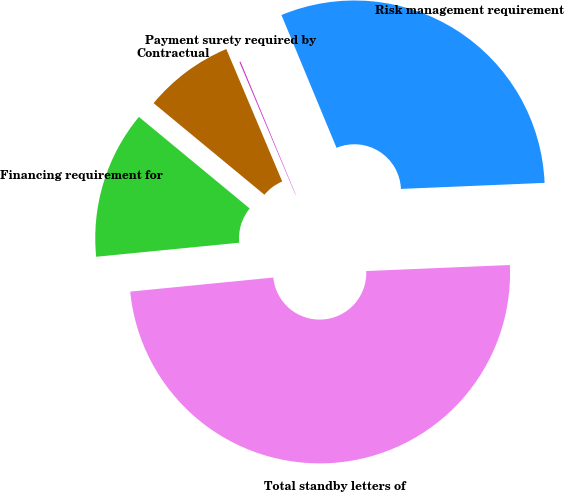Convert chart. <chart><loc_0><loc_0><loc_500><loc_500><pie_chart><fcel>Risk management requirement<fcel>Payment surety required by<fcel>Contractual<fcel>Financing requirement for<fcel>Total standby letters of<nl><fcel>30.59%<fcel>0.1%<fcel>7.65%<fcel>12.55%<fcel>49.11%<nl></chart> 